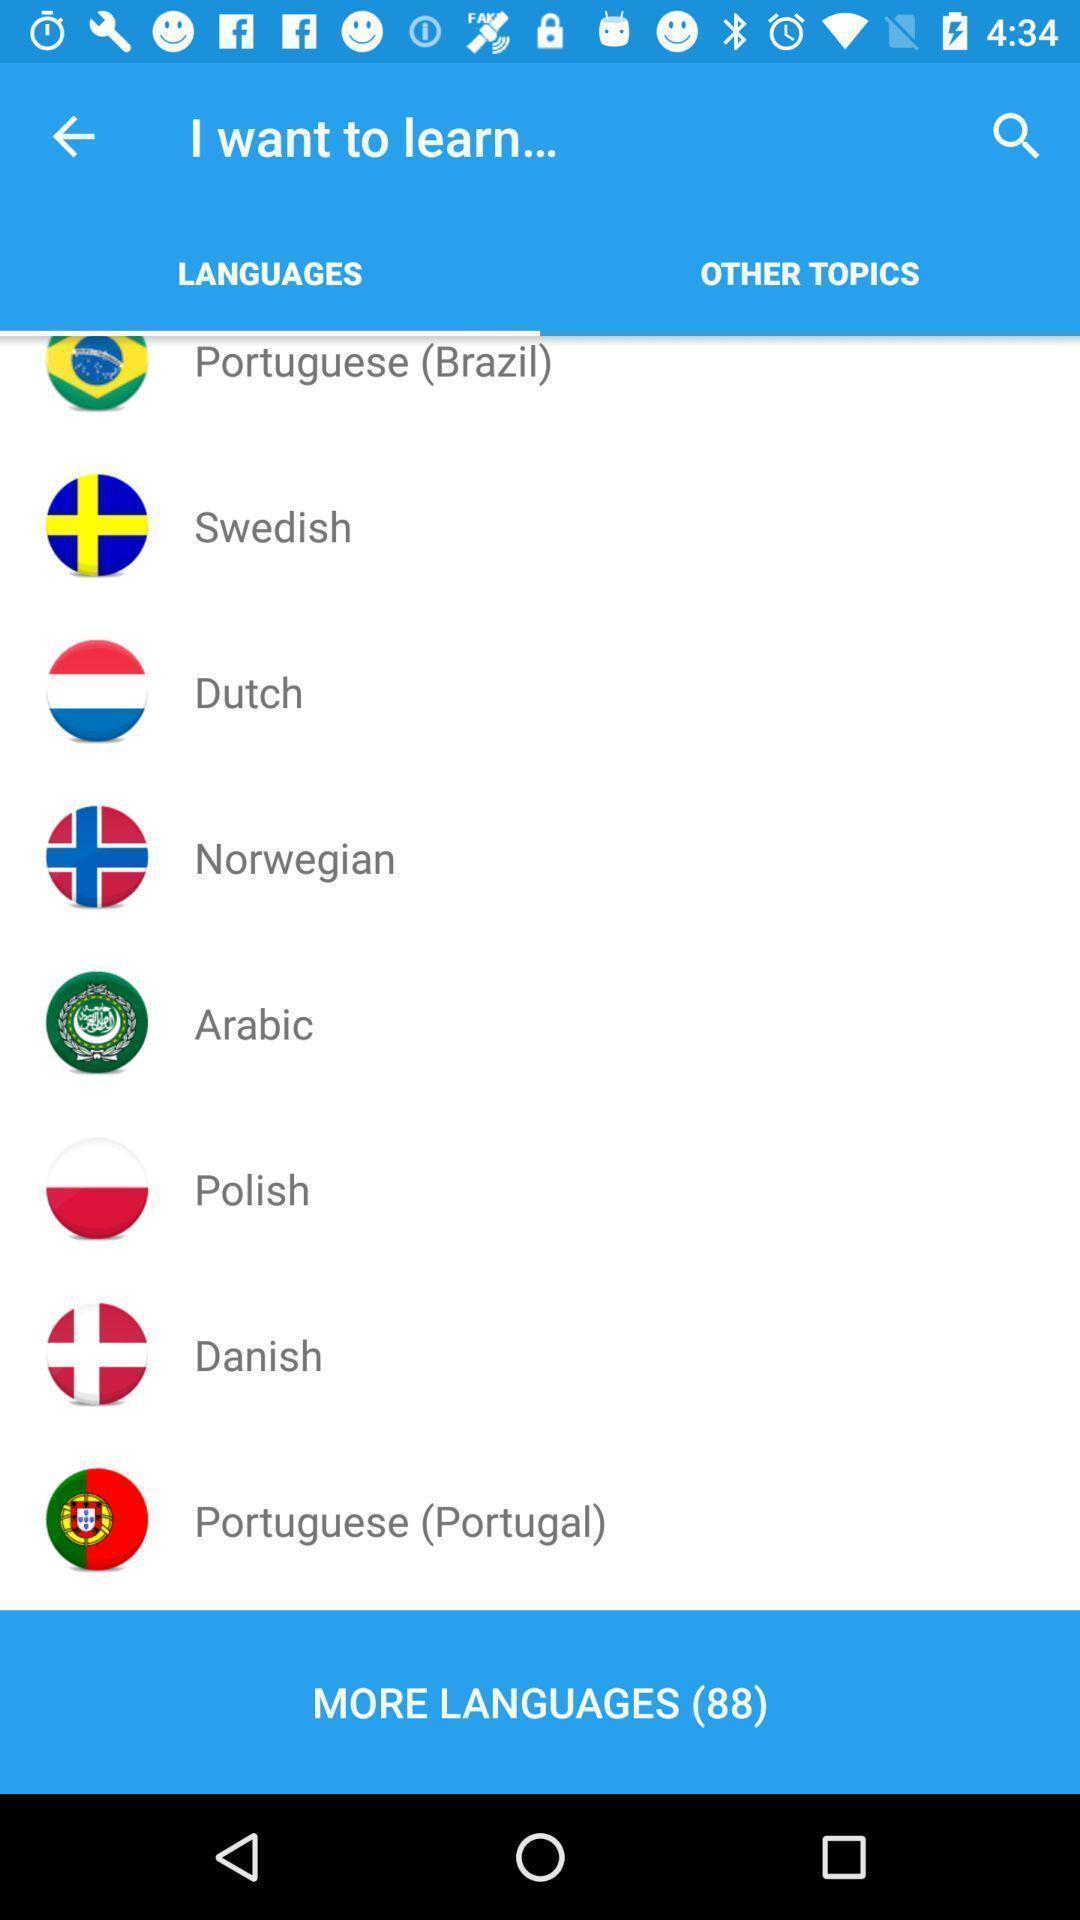What can you discern from this picture? Page shows to select a language for learning. 